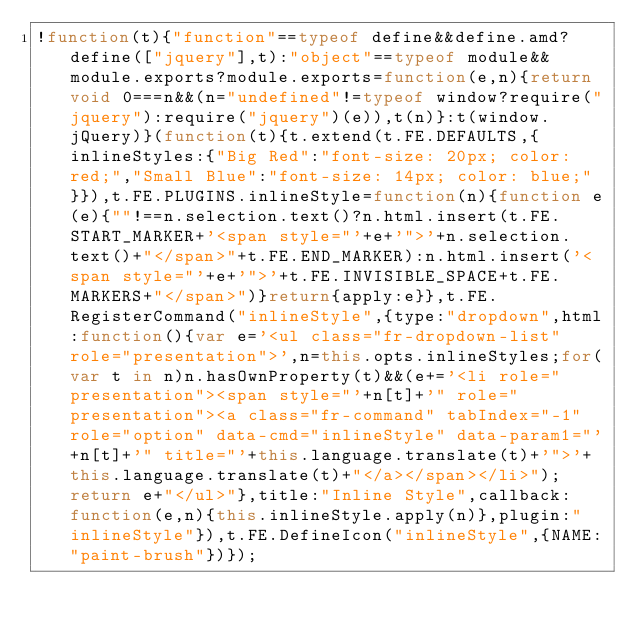Convert code to text. <code><loc_0><loc_0><loc_500><loc_500><_JavaScript_>!function(t){"function"==typeof define&&define.amd?define(["jquery"],t):"object"==typeof module&&module.exports?module.exports=function(e,n){return void 0===n&&(n="undefined"!=typeof window?require("jquery"):require("jquery")(e)),t(n)}:t(window.jQuery)}(function(t){t.extend(t.FE.DEFAULTS,{inlineStyles:{"Big Red":"font-size: 20px; color: red;","Small Blue":"font-size: 14px; color: blue;"}}),t.FE.PLUGINS.inlineStyle=function(n){function e(e){""!==n.selection.text()?n.html.insert(t.FE.START_MARKER+'<span style="'+e+'">'+n.selection.text()+"</span>"+t.FE.END_MARKER):n.html.insert('<span style="'+e+'">'+t.FE.INVISIBLE_SPACE+t.FE.MARKERS+"</span>")}return{apply:e}},t.FE.RegisterCommand("inlineStyle",{type:"dropdown",html:function(){var e='<ul class="fr-dropdown-list" role="presentation">',n=this.opts.inlineStyles;for(var t in n)n.hasOwnProperty(t)&&(e+='<li role="presentation"><span style="'+n[t]+'" role="presentation"><a class="fr-command" tabIndex="-1" role="option" data-cmd="inlineStyle" data-param1="'+n[t]+'" title="'+this.language.translate(t)+'">'+this.language.translate(t)+"</a></span></li>");return e+"</ul>"},title:"Inline Style",callback:function(e,n){this.inlineStyle.apply(n)},plugin:"inlineStyle"}),t.FE.DefineIcon("inlineStyle",{NAME:"paint-brush"})});</code> 